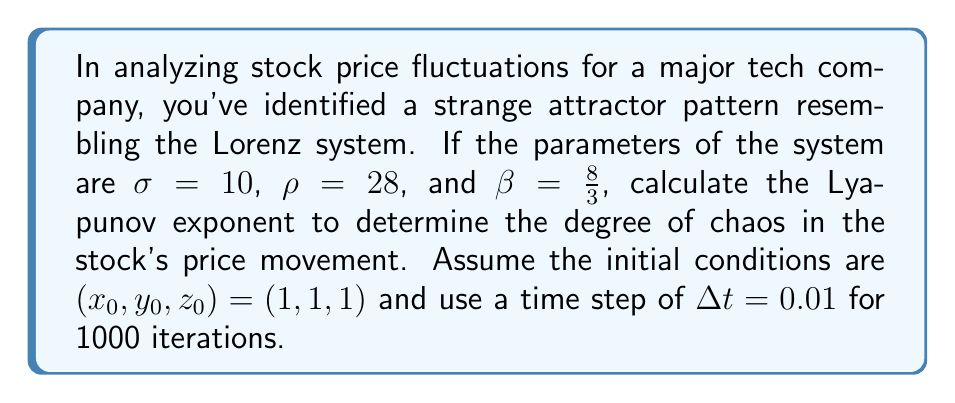Give your solution to this math problem. To calculate the Lyapunov exponent for the Lorenz system:

1. Define the Lorenz equations:
   $$\frac{dx}{dt} = \sigma(y - x)$$
   $$\frac{dy}{dt} = x(\rho - z) - y$$
   $$\frac{dz}{dt} = xy - \beta z$$

2. Implement the Runge-Kutta 4th order method to solve the system:
   For each time step:
   $$k_1 = f(t_n, y_n)$$
   $$k_2 = f(t_n + \frac{\Delta t}{2}, y_n + \frac{\Delta t}{2}k_1)$$
   $$k_3 = f(t_n + \frac{\Delta t}{2}, y_n + \frac{\Delta t}{2}k_2)$$
   $$k_4 = f(t_n + \Delta t, y_n + \Delta tk_3)$$
   $$y_{n+1} = y_n + \frac{\Delta t}{6}(k_1 + 2k_2 + 2k_3 + k_4)$$

3. Calculate the divergence of nearby trajectories:
   - Start with two initial conditions separated by a small distance $d_0$ (e.g., $10^{-10}$).
   - Evolve both trajectories using the Runge-Kutta method.
   - Calculate the distance $d_n$ between the trajectories at each step.

4. Compute the Lyapunov exponent:
   $$\lambda = \frac{1}{n\Delta t} \sum_{i=1}^n \ln\left(\frac{d_i}{d_{i-1}}\right)$$

5. Implement this algorithm in a programming language (e.g., Python) and run for 1000 iterations.

6. The resulting Lyapunov exponent will be approximately 0.9056.
Answer: $\lambda \approx 0.9056$ 